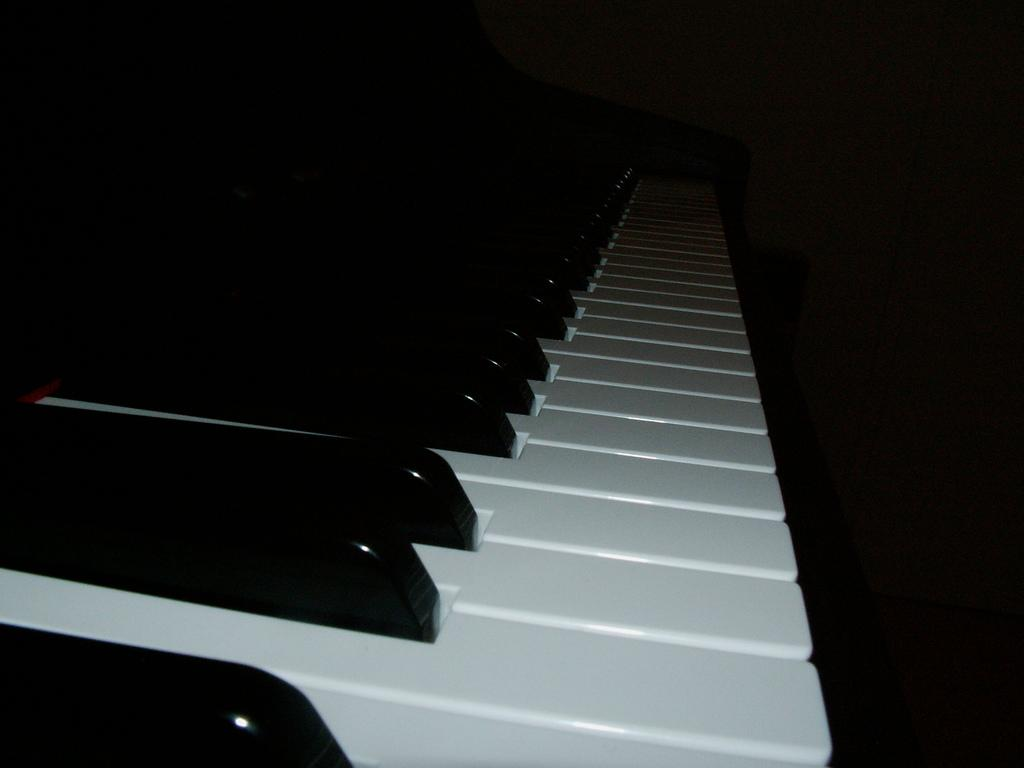What musical instrument is in the image? There is a piano in the image. What feature of the piano is visible in the image? The piano has keys. What color is the background of the image? The background of the image is black. What statement does the queen make in the morning in the image? There is no queen or statement present in the image; it only features a piano with keys against a black background. 